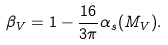Convert formula to latex. <formula><loc_0><loc_0><loc_500><loc_500>\beta _ { V } = 1 - \frac { 1 6 } { 3 \pi } \alpha _ { s } ( M _ { V } ) .</formula> 